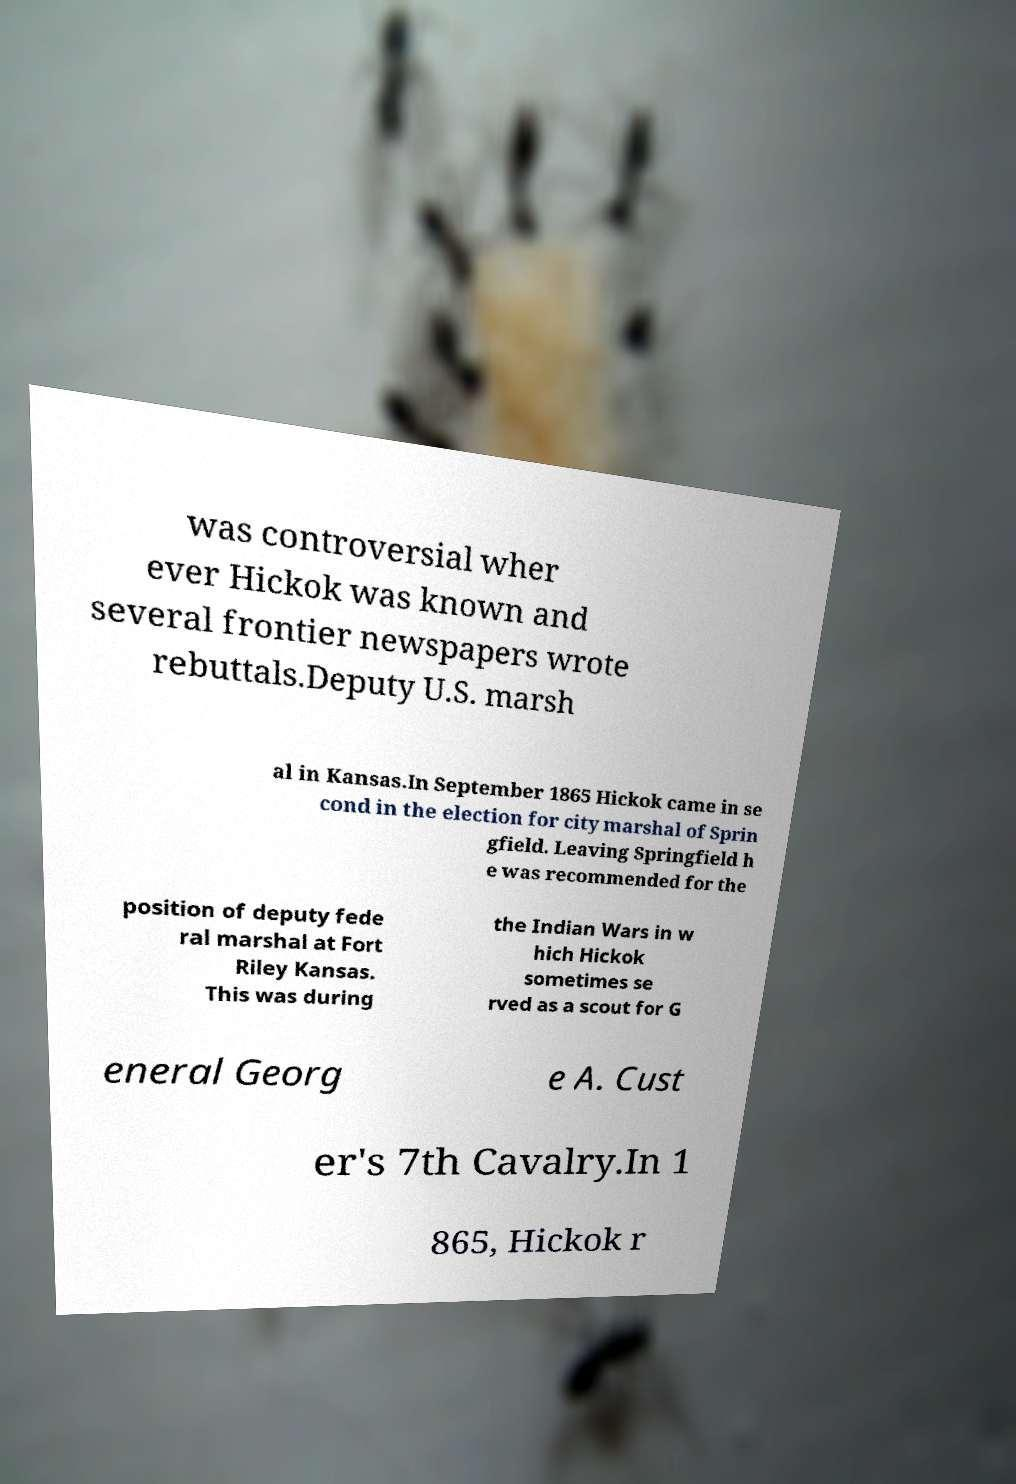What messages or text are displayed in this image? I need them in a readable, typed format. was controversial wher ever Hickok was known and several frontier newspapers wrote rebuttals.Deputy U.S. marsh al in Kansas.In September 1865 Hickok came in se cond in the election for city marshal of Sprin gfield. Leaving Springfield h e was recommended for the position of deputy fede ral marshal at Fort Riley Kansas. This was during the Indian Wars in w hich Hickok sometimes se rved as a scout for G eneral Georg e A. Cust er's 7th Cavalry.In 1 865, Hickok r 